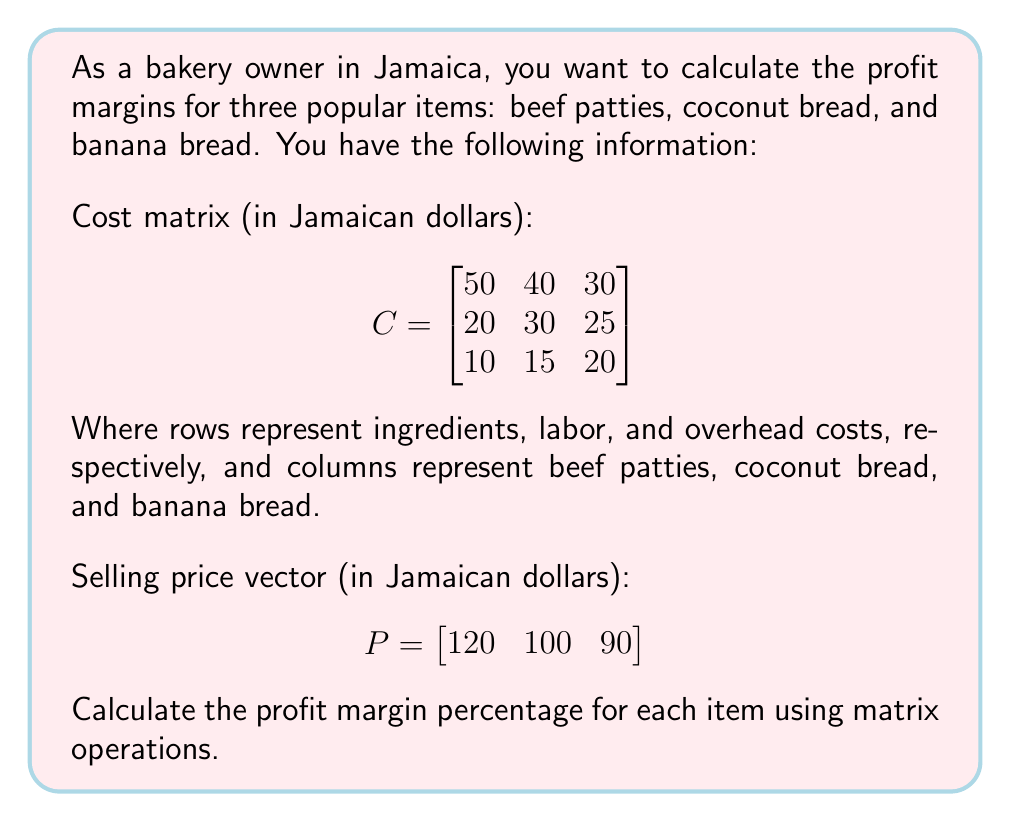Teach me how to tackle this problem. Let's solve this step-by-step:

1) First, we need to calculate the total cost for each item. We can do this by summing the columns of the cost matrix C:

   $$\text{Total Cost} = \begin{bmatrix}
   1 & 1 & 1
   \end{bmatrix} \cdot \begin{bmatrix}
   50 & 40 & 30 \\
   20 & 30 & 25 \\
   10 & 15 & 20
   \end{bmatrix} = \begin{bmatrix}
   80 & 85 & 75
   \end{bmatrix}$$

2) Now, we can calculate the profit for each item by subtracting the total cost from the selling price:

   $$\text{Profit} = P - \text{Total Cost} = \begin{bmatrix}
   120 & 100 & 90
   \end{bmatrix} - \begin{bmatrix}
   80 & 85 & 75
   \end{bmatrix} = \begin{bmatrix}
   40 & 15 & 15
   \end{bmatrix}$$

3) To calculate the profit margin percentage, we divide the profit by the selling price and multiply by 100:

   $$\text{Profit Margin %} = \frac{\text{Profit}}{P} \cdot 100\%$$

   We can do this element-wise:

   $$\begin{bmatrix}
   \frac{40}{120} & \frac{15}{100} & \frac{15}{90}
   \end{bmatrix} \cdot 100\% = \begin{bmatrix}
   33.33\% & 15\% & 16.67\%
   \end{bmatrix}$$
Answer: $\begin{bmatrix} 33.33\% & 15\% & 16.67\% \end{bmatrix}$ 